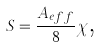<formula> <loc_0><loc_0><loc_500><loc_500>S = \frac { A _ { e f f } } { 8 } \chi \text {,}</formula> 